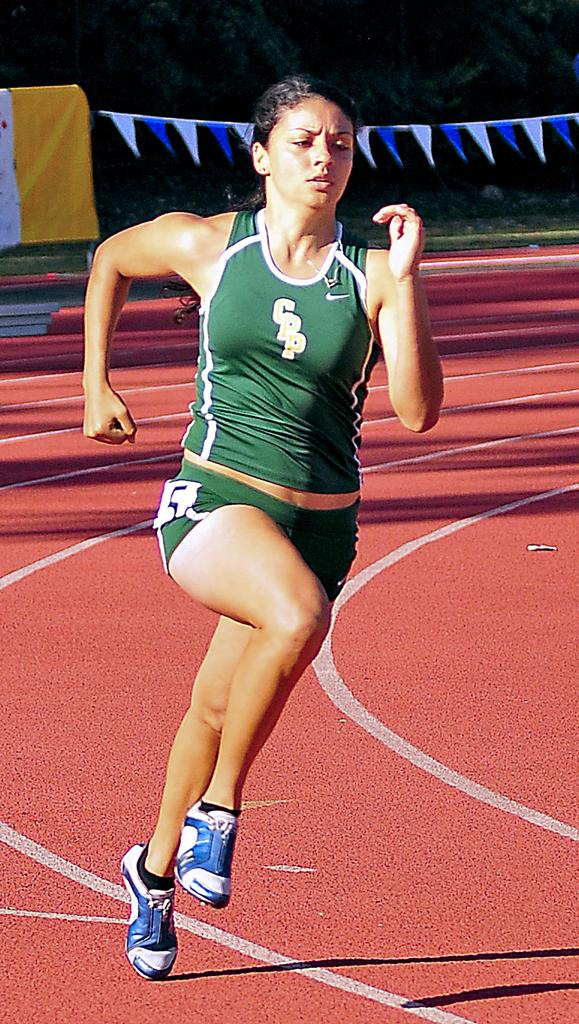<image>
Offer a succinct explanation of the picture presented. Girl running while wearing a shirt which says CPP. 